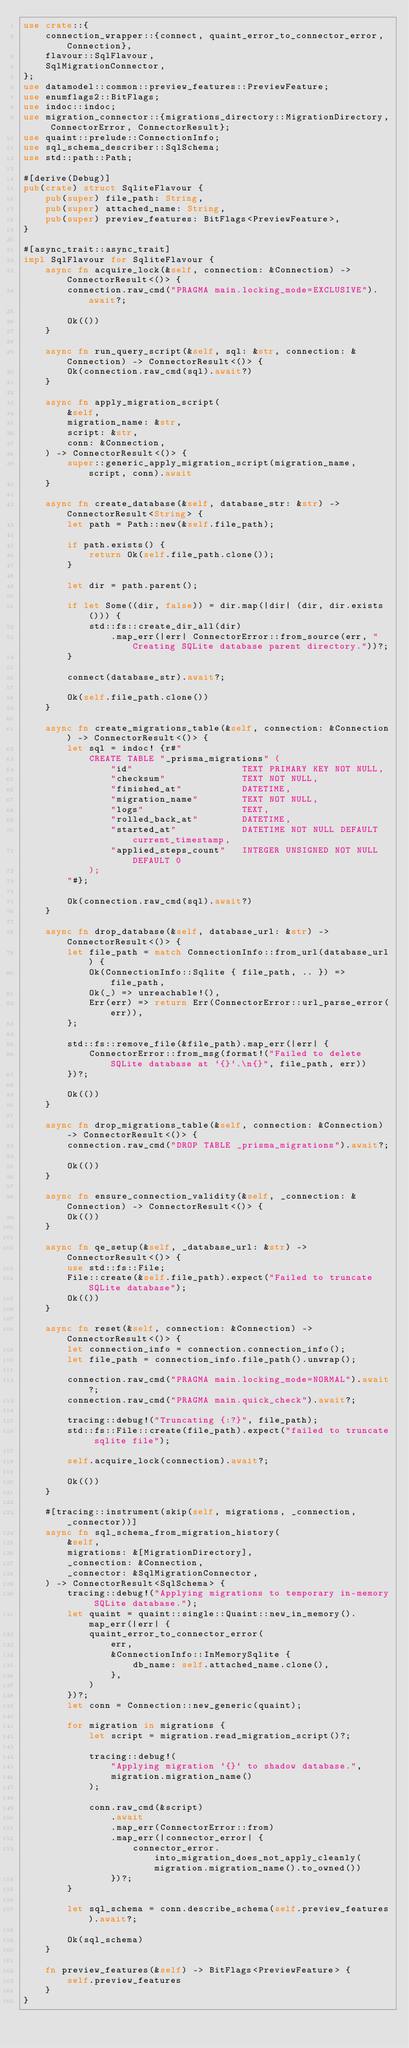<code> <loc_0><loc_0><loc_500><loc_500><_Rust_>use crate::{
    connection_wrapper::{connect, quaint_error_to_connector_error, Connection},
    flavour::SqlFlavour,
    SqlMigrationConnector,
};
use datamodel::common::preview_features::PreviewFeature;
use enumflags2::BitFlags;
use indoc::indoc;
use migration_connector::{migrations_directory::MigrationDirectory, ConnectorError, ConnectorResult};
use quaint::prelude::ConnectionInfo;
use sql_schema_describer::SqlSchema;
use std::path::Path;

#[derive(Debug)]
pub(crate) struct SqliteFlavour {
    pub(super) file_path: String,
    pub(super) attached_name: String,
    pub(super) preview_features: BitFlags<PreviewFeature>,
}

#[async_trait::async_trait]
impl SqlFlavour for SqliteFlavour {
    async fn acquire_lock(&self, connection: &Connection) -> ConnectorResult<()> {
        connection.raw_cmd("PRAGMA main.locking_mode=EXCLUSIVE").await?;

        Ok(())
    }

    async fn run_query_script(&self, sql: &str, connection: &Connection) -> ConnectorResult<()> {
        Ok(connection.raw_cmd(sql).await?)
    }

    async fn apply_migration_script(
        &self,
        migration_name: &str,
        script: &str,
        conn: &Connection,
    ) -> ConnectorResult<()> {
        super::generic_apply_migration_script(migration_name, script, conn).await
    }

    async fn create_database(&self, database_str: &str) -> ConnectorResult<String> {
        let path = Path::new(&self.file_path);

        if path.exists() {
            return Ok(self.file_path.clone());
        }

        let dir = path.parent();

        if let Some((dir, false)) = dir.map(|dir| (dir, dir.exists())) {
            std::fs::create_dir_all(dir)
                .map_err(|err| ConnectorError::from_source(err, "Creating SQLite database parent directory."))?;
        }

        connect(database_str).await?;

        Ok(self.file_path.clone())
    }

    async fn create_migrations_table(&self, connection: &Connection) -> ConnectorResult<()> {
        let sql = indoc! {r#"
            CREATE TABLE "_prisma_migrations" (
                "id"                    TEXT PRIMARY KEY NOT NULL,
                "checksum"              TEXT NOT NULL,
                "finished_at"           DATETIME,
                "migration_name"        TEXT NOT NULL,
                "logs"                  TEXT,
                "rolled_back_at"        DATETIME,
                "started_at"            DATETIME NOT NULL DEFAULT current_timestamp,
                "applied_steps_count"   INTEGER UNSIGNED NOT NULL DEFAULT 0
            );
        "#};

        Ok(connection.raw_cmd(sql).await?)
    }

    async fn drop_database(&self, database_url: &str) -> ConnectorResult<()> {
        let file_path = match ConnectionInfo::from_url(database_url) {
            Ok(ConnectionInfo::Sqlite { file_path, .. }) => file_path,
            Ok(_) => unreachable!(),
            Err(err) => return Err(ConnectorError::url_parse_error(err)),
        };

        std::fs::remove_file(&file_path).map_err(|err| {
            ConnectorError::from_msg(format!("Failed to delete SQLite database at `{}`.\n{}", file_path, err))
        })?;

        Ok(())
    }

    async fn drop_migrations_table(&self, connection: &Connection) -> ConnectorResult<()> {
        connection.raw_cmd("DROP TABLE _prisma_migrations").await?;

        Ok(())
    }

    async fn ensure_connection_validity(&self, _connection: &Connection) -> ConnectorResult<()> {
        Ok(())
    }

    async fn qe_setup(&self, _database_url: &str) -> ConnectorResult<()> {
        use std::fs::File;
        File::create(&self.file_path).expect("Failed to truncate SQLite database");
        Ok(())
    }

    async fn reset(&self, connection: &Connection) -> ConnectorResult<()> {
        let connection_info = connection.connection_info();
        let file_path = connection_info.file_path().unwrap();

        connection.raw_cmd("PRAGMA main.locking_mode=NORMAL").await?;
        connection.raw_cmd("PRAGMA main.quick_check").await?;

        tracing::debug!("Truncating {:?}", file_path);
        std::fs::File::create(file_path).expect("failed to truncate sqlite file");

        self.acquire_lock(connection).await?;

        Ok(())
    }

    #[tracing::instrument(skip(self, migrations, _connection, _connector))]
    async fn sql_schema_from_migration_history(
        &self,
        migrations: &[MigrationDirectory],
        _connection: &Connection,
        _connector: &SqlMigrationConnector,
    ) -> ConnectorResult<SqlSchema> {
        tracing::debug!("Applying migrations to temporary in-memory SQLite database.");
        let quaint = quaint::single::Quaint::new_in_memory().map_err(|err| {
            quaint_error_to_connector_error(
                err,
                &ConnectionInfo::InMemorySqlite {
                    db_name: self.attached_name.clone(),
                },
            )
        })?;
        let conn = Connection::new_generic(quaint);

        for migration in migrations {
            let script = migration.read_migration_script()?;

            tracing::debug!(
                "Applying migration `{}` to shadow database.",
                migration.migration_name()
            );

            conn.raw_cmd(&script)
                .await
                .map_err(ConnectorError::from)
                .map_err(|connector_error| {
                    connector_error.into_migration_does_not_apply_cleanly(migration.migration_name().to_owned())
                })?;
        }

        let sql_schema = conn.describe_schema(self.preview_features).await?;

        Ok(sql_schema)
    }

    fn preview_features(&self) -> BitFlags<PreviewFeature> {
        self.preview_features
    }
}
</code> 